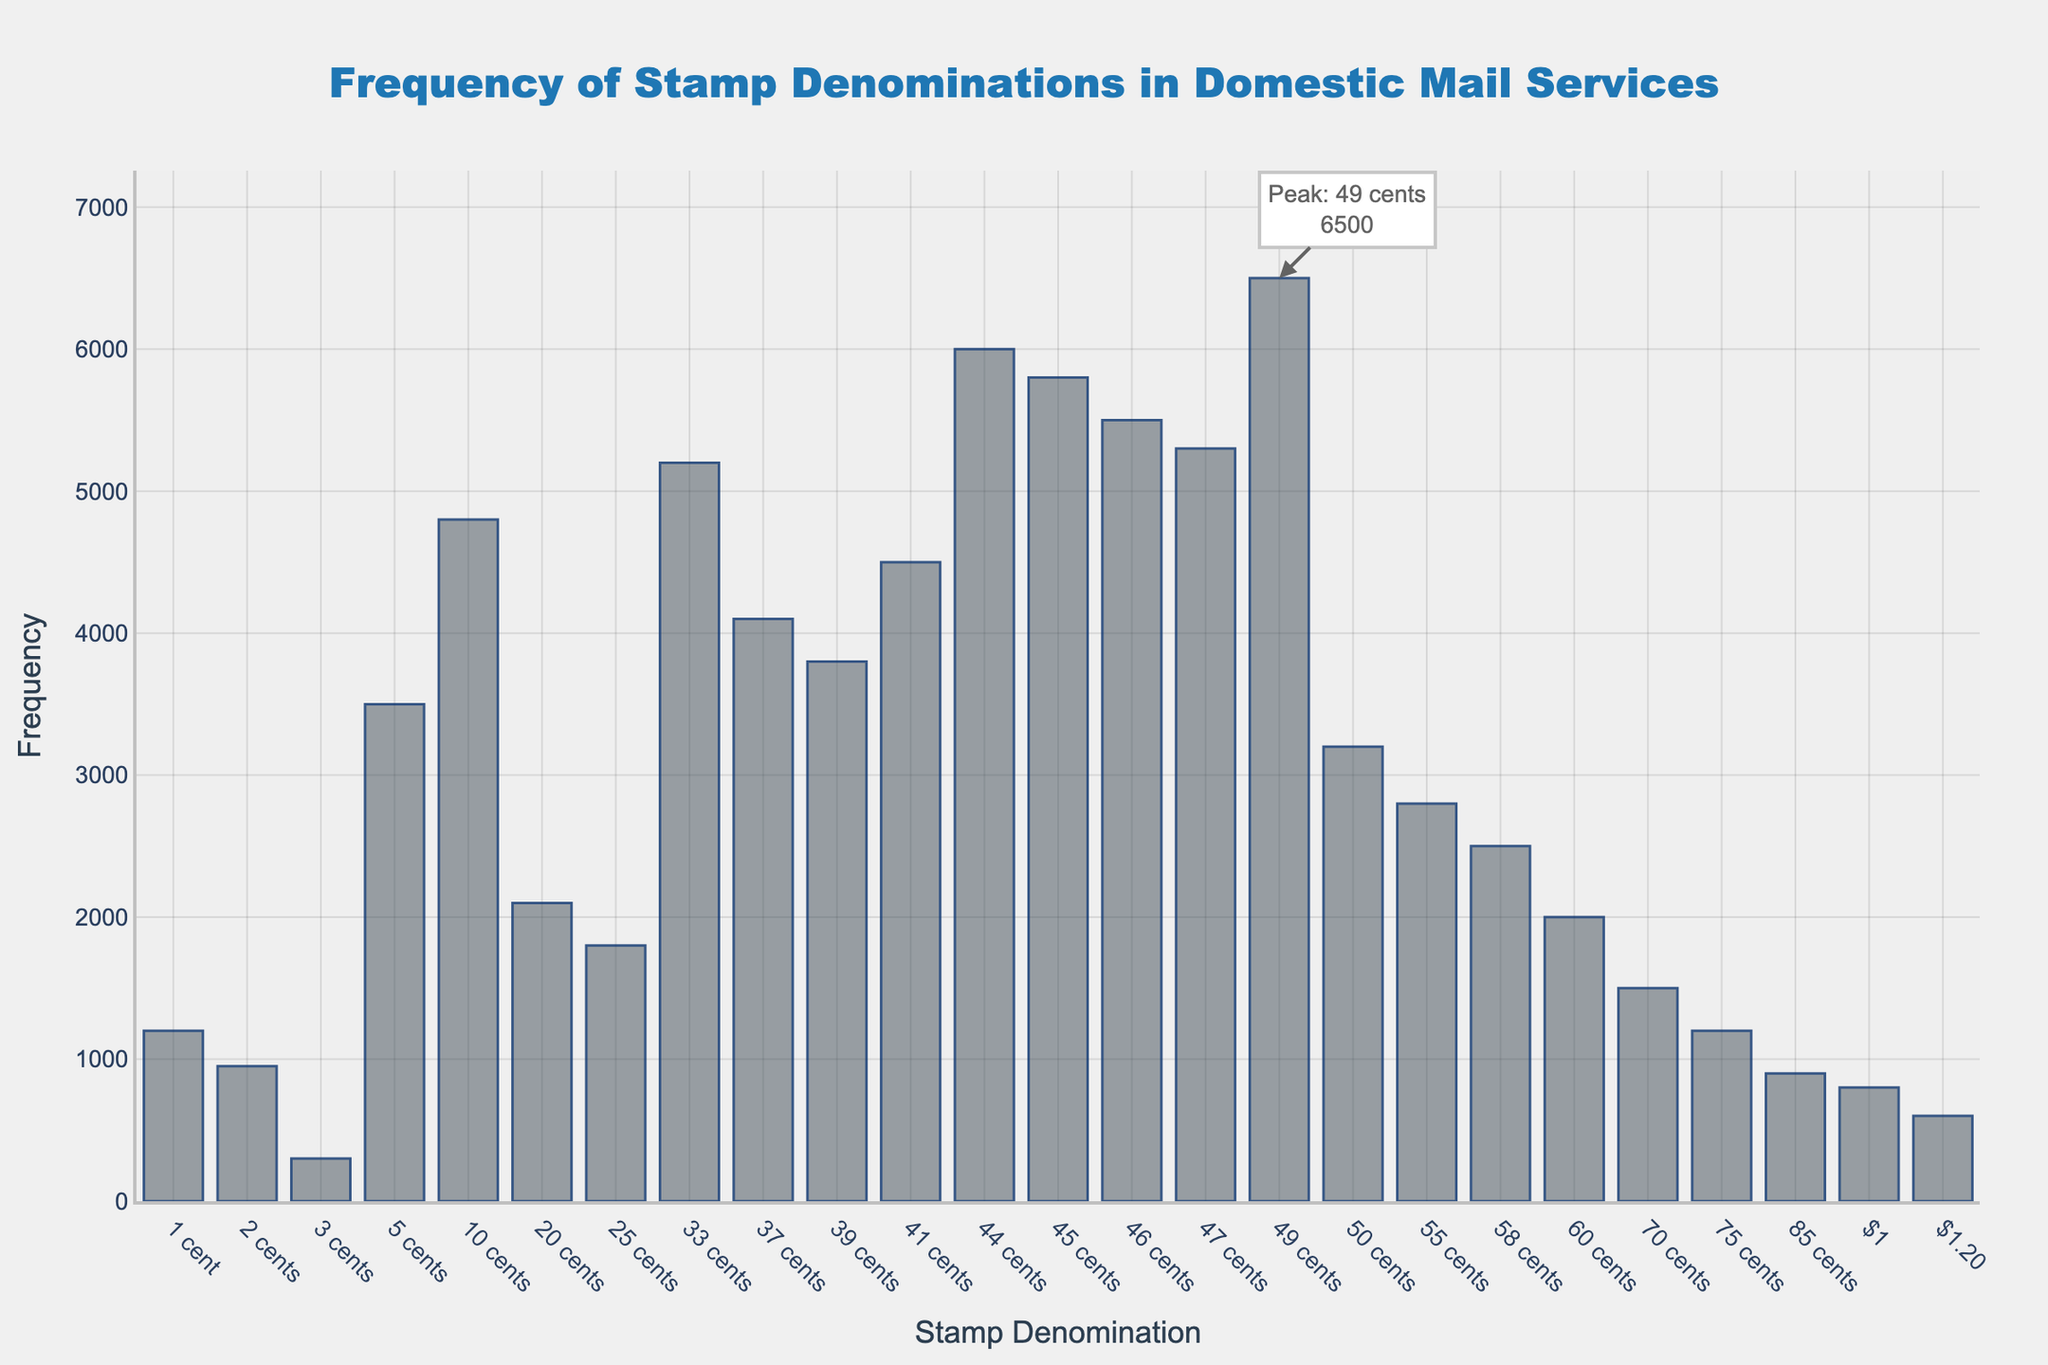What's the title of the plot? The title is typically found at the top of the plot where it summarizes the main idea of the chart.
Answer: Frequency of Stamp Denominations in Domestic Mail Services What is the most frequently used stamp denomination? Observe the bar height representing frequencies. The tallest bar denotes the highest frequency. The denomination at the peak's x-axis is the most frequently used.
Answer: 49 cents What stamp denomination has the least frequency and what is its value? Look for the shortest bar as it represents the lowest frequency. Identify the denomination and read the value from the y-axis.
Answer: $1.20, 600 Which denomination has a higher frequency, 44 cents or 45 cents? Compare the heights of the bars at 44 cents and 45 cents. The taller bar indicates a higher frequency.
Answer: 44 cents What is the total frequency of stamps from 1 cent to 3 cents? Sum the frequencies of the 1 cent, 2 cents, and 3 cents bars.
Answer: 1200 + 950 + 300 = 2450 What is the second highest frequency, and which denomination does it belong to? Identify the second tallest bar after the peak and note its y-axis value and denomination.
Answer: 44 cents, 6000 How many denominations have a frequency greater than 5000? Count the bars whose heights exceed the 5000 frequency mark on the y-axis.
Answer: 4 Which has a higher frequency, 50 cents or 55 cents stamps? Compare the heights of the bars corresponding to 50 cents and 55 cents. The taller bar indicates the higher frequency.
Answer: 50 cents What is the combined frequency of the stamps at 33 cents and 37 cents? Add the frequencies of the bars at 33 cents and 37 cents.
Answer: 5200 + 4100 = 9300 What is the frequency range of the stamp denominations from 1 cent to $1? Subtract the lowest frequency from the highest frequency within the denominations from 1 cent to $1.
Answer: 6500 - 600 = 5900 